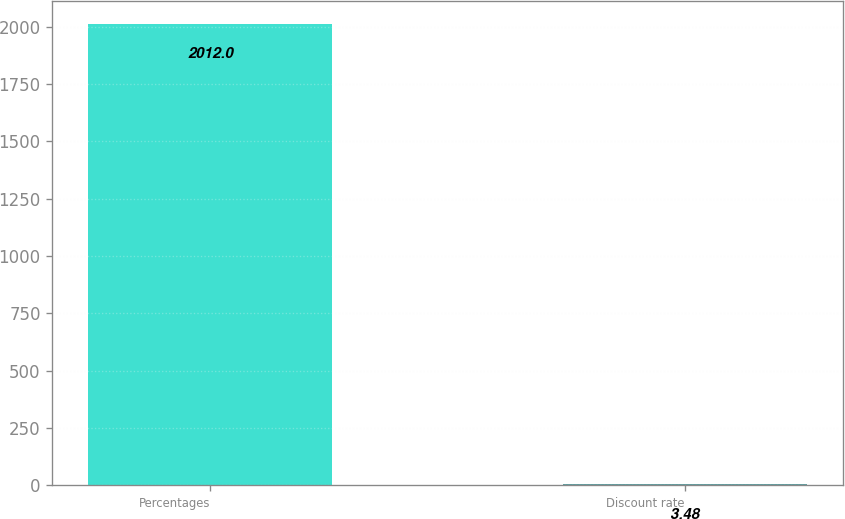Convert chart to OTSL. <chart><loc_0><loc_0><loc_500><loc_500><bar_chart><fcel>Percentages<fcel>Discount rate<nl><fcel>2012<fcel>3.48<nl></chart> 